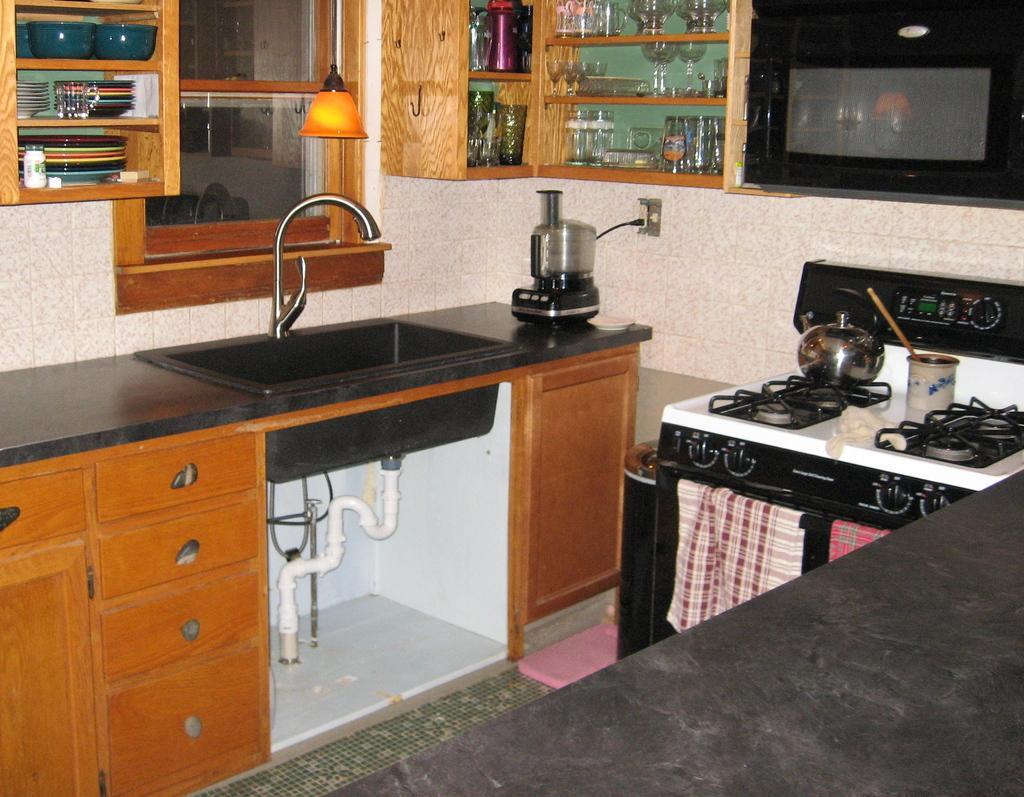Could you give a brief overview of what you see in this image? In this image there is a shrink in the middle. Above the sink there are cupboards in which there are bowls,plates and glasses. On the right side there is a stove on which there is a vessel. On the right side top there is an oven. There is a juice mixture on the desk. At the bottom there are drawers. There are two kerchiefs which are hanged on the pole. 